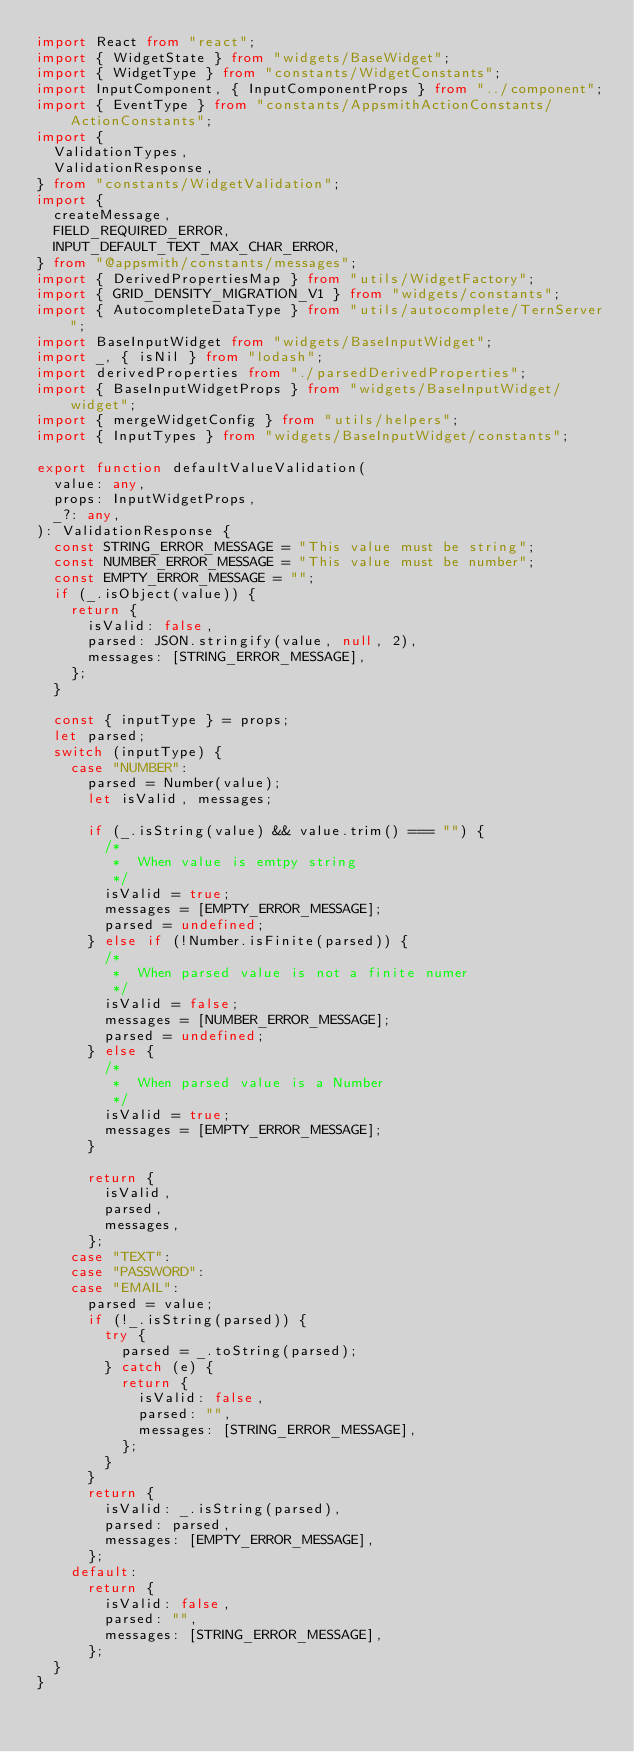Convert code to text. <code><loc_0><loc_0><loc_500><loc_500><_TypeScript_>import React from "react";
import { WidgetState } from "widgets/BaseWidget";
import { WidgetType } from "constants/WidgetConstants";
import InputComponent, { InputComponentProps } from "../component";
import { EventType } from "constants/AppsmithActionConstants/ActionConstants";
import {
  ValidationTypes,
  ValidationResponse,
} from "constants/WidgetValidation";
import {
  createMessage,
  FIELD_REQUIRED_ERROR,
  INPUT_DEFAULT_TEXT_MAX_CHAR_ERROR,
} from "@appsmith/constants/messages";
import { DerivedPropertiesMap } from "utils/WidgetFactory";
import { GRID_DENSITY_MIGRATION_V1 } from "widgets/constants";
import { AutocompleteDataType } from "utils/autocomplete/TernServer";
import BaseInputWidget from "widgets/BaseInputWidget";
import _, { isNil } from "lodash";
import derivedProperties from "./parsedDerivedProperties";
import { BaseInputWidgetProps } from "widgets/BaseInputWidget/widget";
import { mergeWidgetConfig } from "utils/helpers";
import { InputTypes } from "widgets/BaseInputWidget/constants";

export function defaultValueValidation(
  value: any,
  props: InputWidgetProps,
  _?: any,
): ValidationResponse {
  const STRING_ERROR_MESSAGE = "This value must be string";
  const NUMBER_ERROR_MESSAGE = "This value must be number";
  const EMPTY_ERROR_MESSAGE = "";
  if (_.isObject(value)) {
    return {
      isValid: false,
      parsed: JSON.stringify(value, null, 2),
      messages: [STRING_ERROR_MESSAGE],
    };
  }

  const { inputType } = props;
  let parsed;
  switch (inputType) {
    case "NUMBER":
      parsed = Number(value);
      let isValid, messages;

      if (_.isString(value) && value.trim() === "") {
        /*
         *  When value is emtpy string
         */
        isValid = true;
        messages = [EMPTY_ERROR_MESSAGE];
        parsed = undefined;
      } else if (!Number.isFinite(parsed)) {
        /*
         *  When parsed value is not a finite numer
         */
        isValid = false;
        messages = [NUMBER_ERROR_MESSAGE];
        parsed = undefined;
      } else {
        /*
         *  When parsed value is a Number
         */
        isValid = true;
        messages = [EMPTY_ERROR_MESSAGE];
      }

      return {
        isValid,
        parsed,
        messages,
      };
    case "TEXT":
    case "PASSWORD":
    case "EMAIL":
      parsed = value;
      if (!_.isString(parsed)) {
        try {
          parsed = _.toString(parsed);
        } catch (e) {
          return {
            isValid: false,
            parsed: "",
            messages: [STRING_ERROR_MESSAGE],
          };
        }
      }
      return {
        isValid: _.isString(parsed),
        parsed: parsed,
        messages: [EMPTY_ERROR_MESSAGE],
      };
    default:
      return {
        isValid: false,
        parsed: "",
        messages: [STRING_ERROR_MESSAGE],
      };
  }
}
</code> 